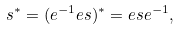Convert formula to latex. <formula><loc_0><loc_0><loc_500><loc_500>s ^ { \ast } = ( e ^ { - 1 } e s ) ^ { \ast } = e s e ^ { - 1 } ,</formula> 